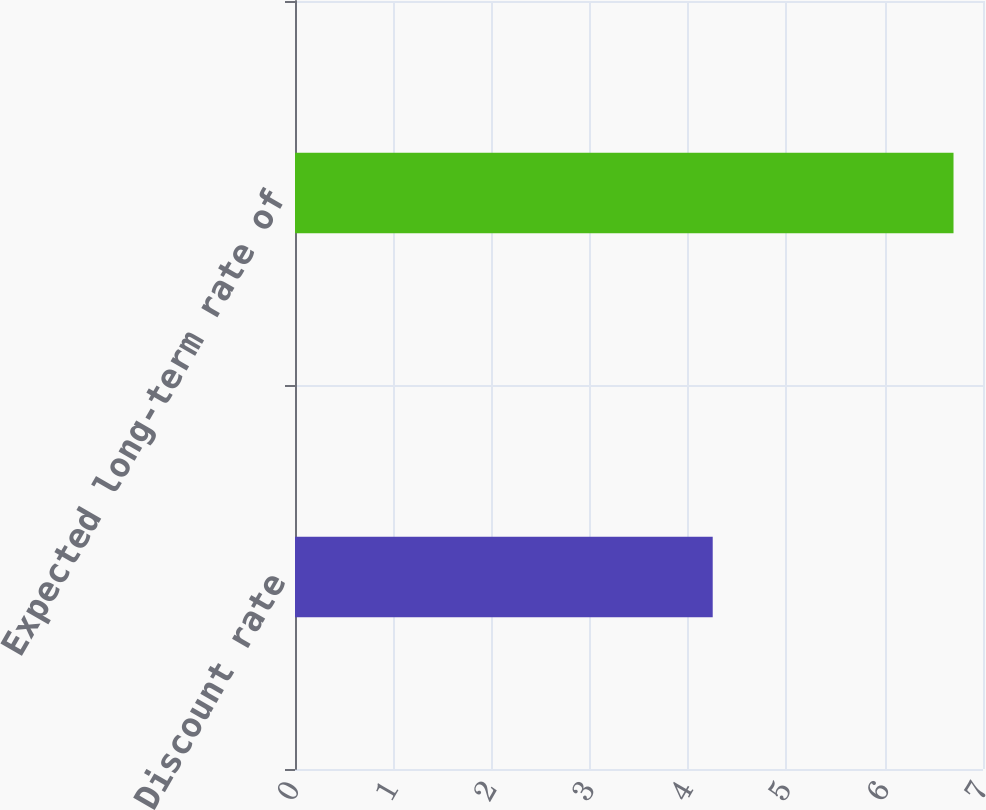Convert chart to OTSL. <chart><loc_0><loc_0><loc_500><loc_500><bar_chart><fcel>Discount rate<fcel>Expected long-term rate of<nl><fcel>4.25<fcel>6.7<nl></chart> 